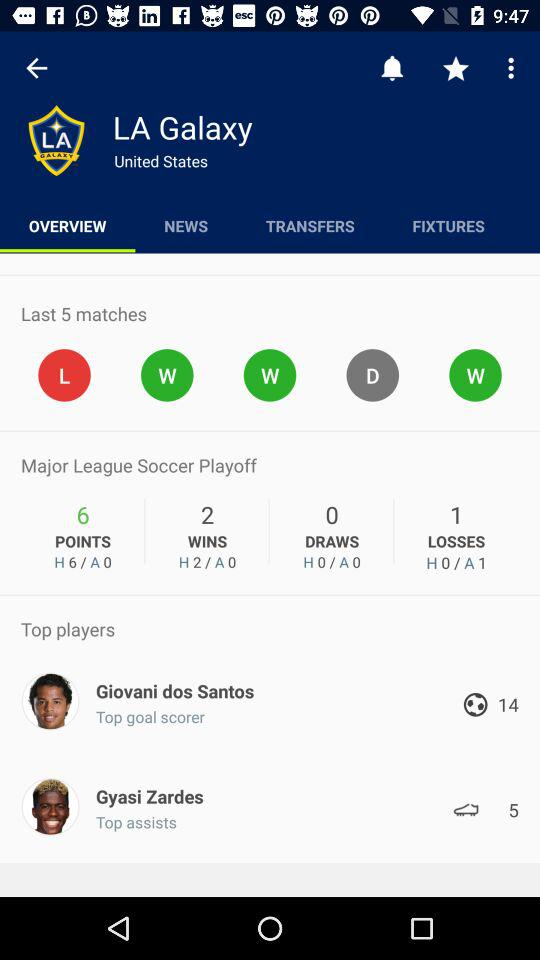How many goals has Giovani dos Santos scored?
Answer the question using a single word or phrase. 14 